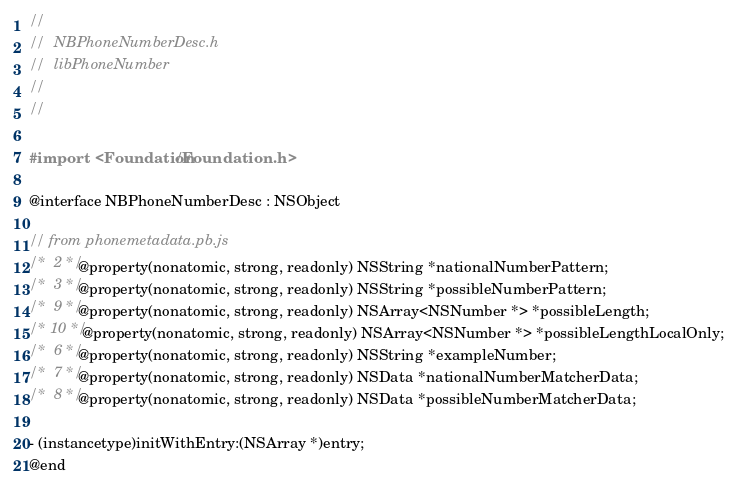Convert code to text. <code><loc_0><loc_0><loc_500><loc_500><_C_>//
//  NBPhoneNumberDesc.h
//  libPhoneNumber
//
//

#import <Foundation/Foundation.h>

@interface NBPhoneNumberDesc : NSObject

// from phonemetadata.pb.js
/*  2 */ @property(nonatomic, strong, readonly) NSString *nationalNumberPattern;
/*  3 */ @property(nonatomic, strong, readonly) NSString *possibleNumberPattern;
/*  9 */ @property(nonatomic, strong, readonly) NSArray<NSNumber *> *possibleLength;
/* 10 */ @property(nonatomic, strong, readonly) NSArray<NSNumber *> *possibleLengthLocalOnly;
/*  6 */ @property(nonatomic, strong, readonly) NSString *exampleNumber;
/*  7 */ @property(nonatomic, strong, readonly) NSData *nationalNumberMatcherData;
/*  8 */ @property(nonatomic, strong, readonly) NSData *possibleNumberMatcherData;

- (instancetype)initWithEntry:(NSArray *)entry;
@end
</code> 